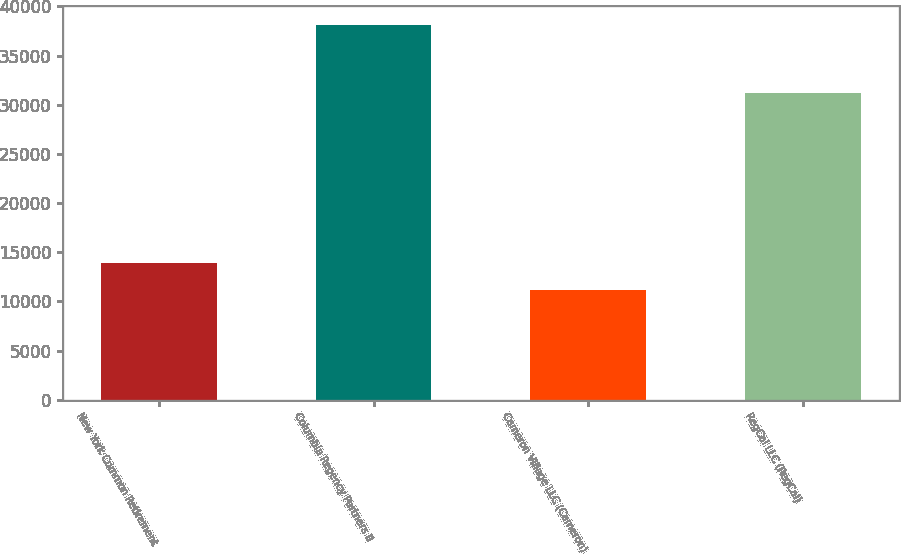Convert chart. <chart><loc_0><loc_0><loc_500><loc_500><bar_chart><fcel>New York Common Retirement<fcel>Columbia Regency Partners II<fcel>Cameron Village LLC (Cameron)<fcel>RegCal LLC (RegCal)<nl><fcel>13863.1<fcel>38110<fcel>11169<fcel>31235<nl></chart> 